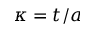Convert formula to latex. <formula><loc_0><loc_0><loc_500><loc_500>\kappa = t / a</formula> 